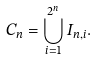Convert formula to latex. <formula><loc_0><loc_0><loc_500><loc_500>C _ { n } = \bigcup _ { i = 1 } ^ { 2 ^ { n } } I _ { n , i } .</formula> 